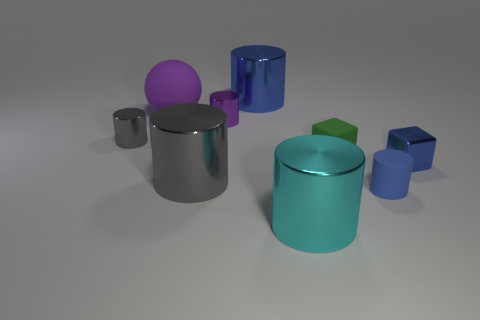Subtract 1 cylinders. How many cylinders are left? 5 Subtract all cyan cylinders. How many cylinders are left? 5 Subtract all small blue cylinders. How many cylinders are left? 5 Subtract all red blocks. Subtract all blue balls. How many blocks are left? 2 Add 1 matte spheres. How many objects exist? 10 Subtract all cubes. How many objects are left? 7 Subtract all metallic blocks. Subtract all spheres. How many objects are left? 7 Add 6 blue cylinders. How many blue cylinders are left? 8 Add 2 big things. How many big things exist? 6 Subtract 0 yellow blocks. How many objects are left? 9 